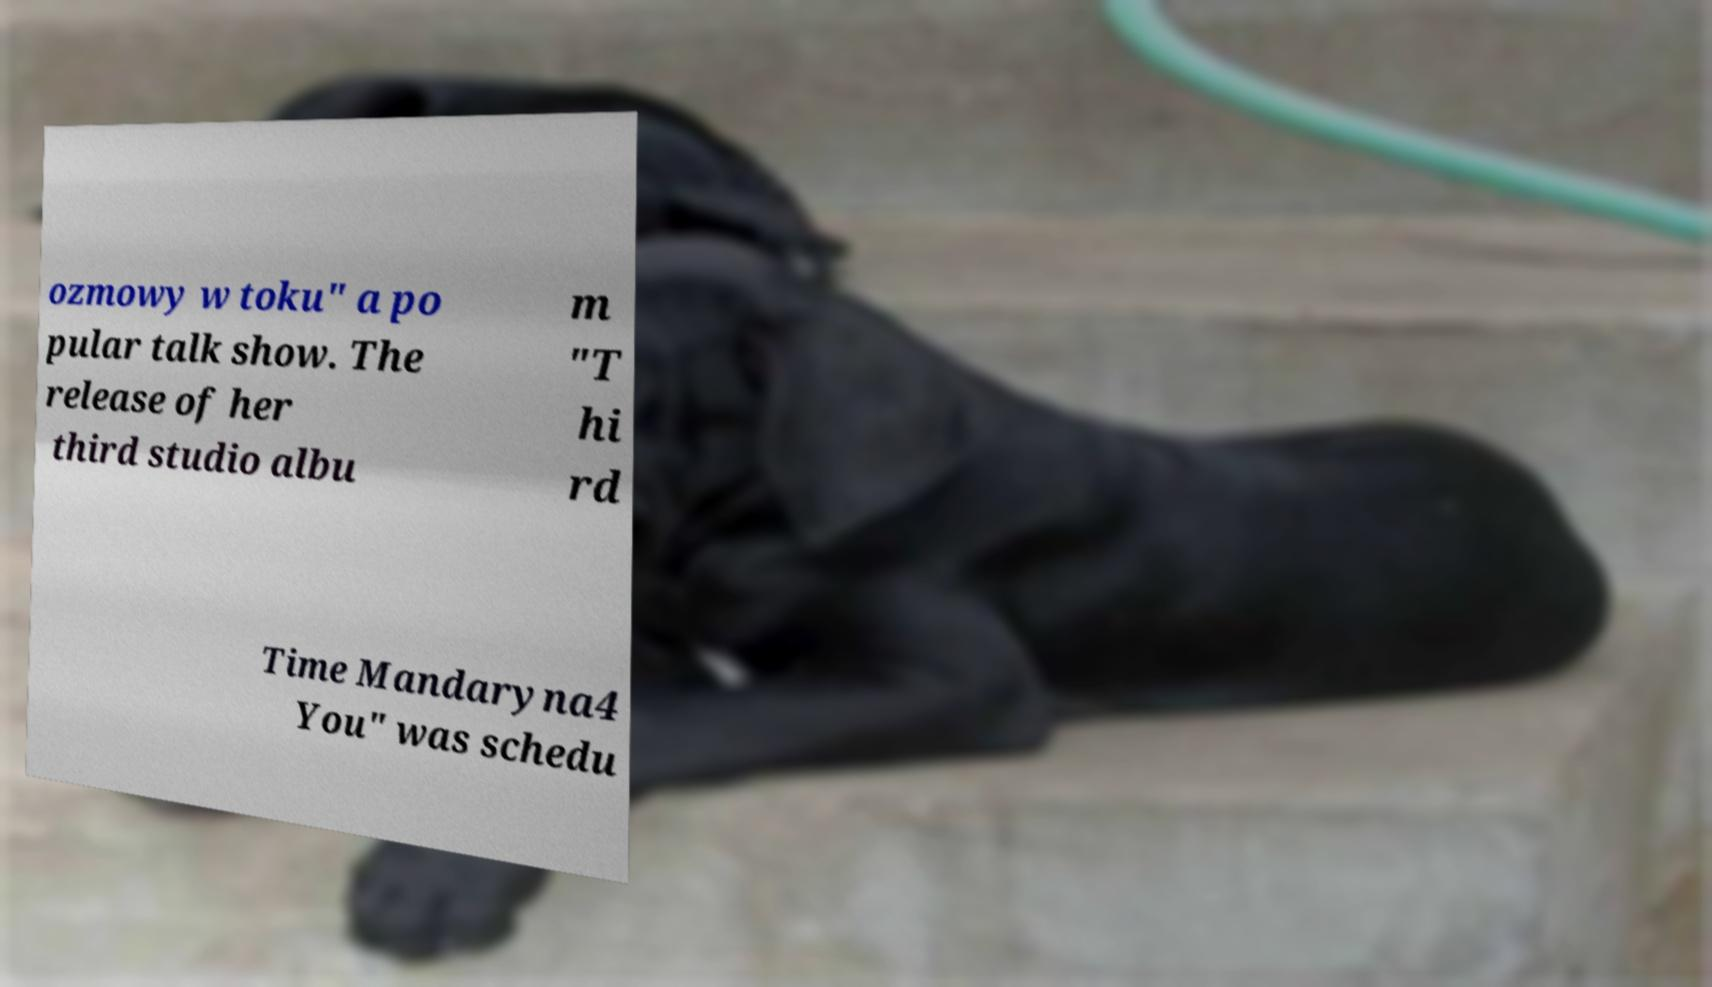Please identify and transcribe the text found in this image. ozmowy w toku" a po pular talk show. The release of her third studio albu m "T hi rd Time Mandaryna4 You" was schedu 